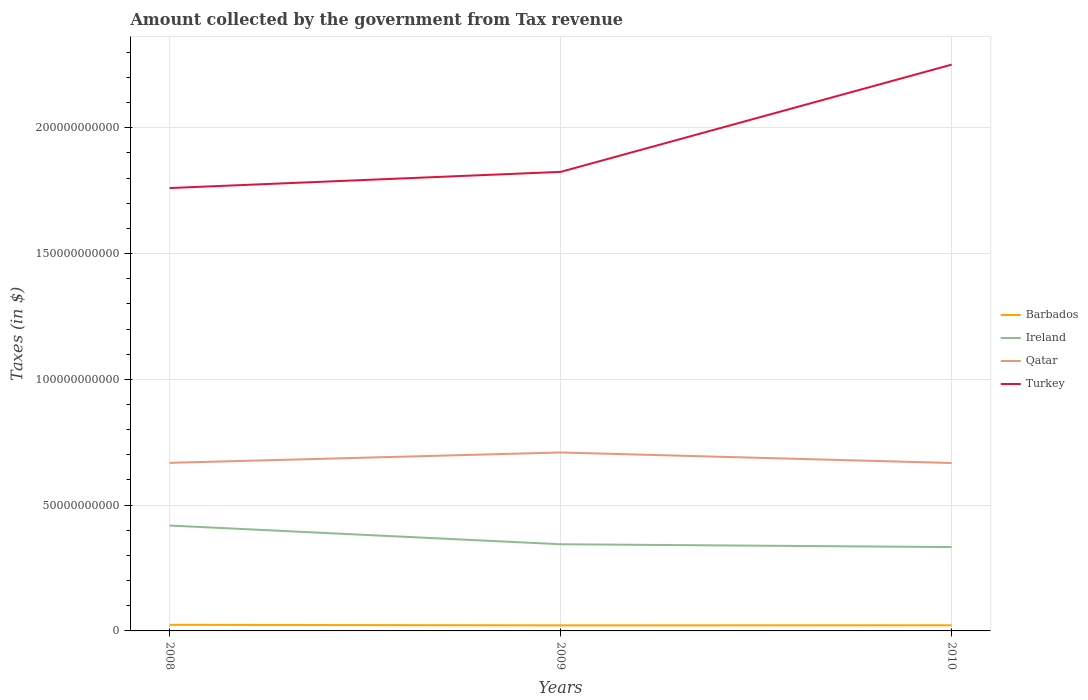Does the line corresponding to Barbados intersect with the line corresponding to Qatar?
Make the answer very short. No. Is the number of lines equal to the number of legend labels?
Provide a succinct answer. Yes. Across all years, what is the maximum amount collected by the government from tax revenue in Turkey?
Your answer should be compact. 1.76e+11. What is the total amount collected by the government from tax revenue in Turkey in the graph?
Your answer should be very brief. -4.91e+1. What is the difference between the highest and the second highest amount collected by the government from tax revenue in Turkey?
Give a very brief answer. 4.91e+1. Is the amount collected by the government from tax revenue in Ireland strictly greater than the amount collected by the government from tax revenue in Qatar over the years?
Provide a succinct answer. Yes. How many years are there in the graph?
Offer a terse response. 3. Does the graph contain grids?
Offer a very short reply. Yes. How many legend labels are there?
Provide a succinct answer. 4. What is the title of the graph?
Provide a short and direct response. Amount collected by the government from Tax revenue. What is the label or title of the X-axis?
Keep it short and to the point. Years. What is the label or title of the Y-axis?
Your answer should be compact. Taxes (in $). What is the Taxes (in $) of Barbados in 2008?
Offer a terse response. 2.43e+09. What is the Taxes (in $) of Ireland in 2008?
Make the answer very short. 4.19e+1. What is the Taxes (in $) of Qatar in 2008?
Your answer should be very brief. 6.68e+1. What is the Taxes (in $) of Turkey in 2008?
Keep it short and to the point. 1.76e+11. What is the Taxes (in $) in Barbados in 2009?
Make the answer very short. 2.21e+09. What is the Taxes (in $) in Ireland in 2009?
Make the answer very short. 3.45e+1. What is the Taxes (in $) in Qatar in 2009?
Make the answer very short. 7.09e+1. What is the Taxes (in $) in Turkey in 2009?
Your answer should be very brief. 1.82e+11. What is the Taxes (in $) of Barbados in 2010?
Offer a very short reply. 2.24e+09. What is the Taxes (in $) in Ireland in 2010?
Your answer should be very brief. 3.33e+1. What is the Taxes (in $) of Qatar in 2010?
Your answer should be compact. 6.67e+1. What is the Taxes (in $) of Turkey in 2010?
Give a very brief answer. 2.25e+11. Across all years, what is the maximum Taxes (in $) in Barbados?
Make the answer very short. 2.43e+09. Across all years, what is the maximum Taxes (in $) of Ireland?
Offer a terse response. 4.19e+1. Across all years, what is the maximum Taxes (in $) of Qatar?
Provide a succinct answer. 7.09e+1. Across all years, what is the maximum Taxes (in $) of Turkey?
Your answer should be compact. 2.25e+11. Across all years, what is the minimum Taxes (in $) of Barbados?
Ensure brevity in your answer.  2.21e+09. Across all years, what is the minimum Taxes (in $) of Ireland?
Provide a short and direct response. 3.33e+1. Across all years, what is the minimum Taxes (in $) in Qatar?
Your answer should be very brief. 6.67e+1. Across all years, what is the minimum Taxes (in $) in Turkey?
Your answer should be very brief. 1.76e+11. What is the total Taxes (in $) in Barbados in the graph?
Your answer should be compact. 6.88e+09. What is the total Taxes (in $) in Ireland in the graph?
Your response must be concise. 1.10e+11. What is the total Taxes (in $) of Qatar in the graph?
Ensure brevity in your answer.  2.04e+11. What is the total Taxes (in $) in Turkey in the graph?
Offer a terse response. 5.84e+11. What is the difference between the Taxes (in $) of Barbados in 2008 and that in 2009?
Ensure brevity in your answer.  2.26e+08. What is the difference between the Taxes (in $) of Ireland in 2008 and that in 2009?
Your response must be concise. 7.44e+09. What is the difference between the Taxes (in $) of Qatar in 2008 and that in 2009?
Give a very brief answer. -4.12e+09. What is the difference between the Taxes (in $) of Turkey in 2008 and that in 2009?
Your answer should be very brief. -6.43e+09. What is the difference between the Taxes (in $) of Barbados in 2008 and that in 2010?
Ensure brevity in your answer.  1.95e+08. What is the difference between the Taxes (in $) in Ireland in 2008 and that in 2010?
Give a very brief answer. 8.56e+09. What is the difference between the Taxes (in $) of Qatar in 2008 and that in 2010?
Provide a short and direct response. 6.57e+07. What is the difference between the Taxes (in $) in Turkey in 2008 and that in 2010?
Your response must be concise. -4.91e+1. What is the difference between the Taxes (in $) in Barbados in 2009 and that in 2010?
Provide a short and direct response. -3.17e+07. What is the difference between the Taxes (in $) in Ireland in 2009 and that in 2010?
Give a very brief answer. 1.13e+09. What is the difference between the Taxes (in $) in Qatar in 2009 and that in 2010?
Offer a very short reply. 4.18e+09. What is the difference between the Taxes (in $) in Turkey in 2009 and that in 2010?
Provide a succinct answer. -4.26e+1. What is the difference between the Taxes (in $) in Barbados in 2008 and the Taxes (in $) in Ireland in 2009?
Offer a terse response. -3.20e+1. What is the difference between the Taxes (in $) of Barbados in 2008 and the Taxes (in $) of Qatar in 2009?
Give a very brief answer. -6.85e+1. What is the difference between the Taxes (in $) of Barbados in 2008 and the Taxes (in $) of Turkey in 2009?
Make the answer very short. -1.80e+11. What is the difference between the Taxes (in $) in Ireland in 2008 and the Taxes (in $) in Qatar in 2009?
Give a very brief answer. -2.90e+1. What is the difference between the Taxes (in $) in Ireland in 2008 and the Taxes (in $) in Turkey in 2009?
Your answer should be very brief. -1.41e+11. What is the difference between the Taxes (in $) of Qatar in 2008 and the Taxes (in $) of Turkey in 2009?
Provide a succinct answer. -1.16e+11. What is the difference between the Taxes (in $) of Barbados in 2008 and the Taxes (in $) of Ireland in 2010?
Keep it short and to the point. -3.09e+1. What is the difference between the Taxes (in $) of Barbados in 2008 and the Taxes (in $) of Qatar in 2010?
Your answer should be compact. -6.43e+1. What is the difference between the Taxes (in $) in Barbados in 2008 and the Taxes (in $) in Turkey in 2010?
Your answer should be compact. -2.23e+11. What is the difference between the Taxes (in $) in Ireland in 2008 and the Taxes (in $) in Qatar in 2010?
Your response must be concise. -2.49e+1. What is the difference between the Taxes (in $) in Ireland in 2008 and the Taxes (in $) in Turkey in 2010?
Make the answer very short. -1.83e+11. What is the difference between the Taxes (in $) in Qatar in 2008 and the Taxes (in $) in Turkey in 2010?
Keep it short and to the point. -1.58e+11. What is the difference between the Taxes (in $) in Barbados in 2009 and the Taxes (in $) in Ireland in 2010?
Your response must be concise. -3.11e+1. What is the difference between the Taxes (in $) of Barbados in 2009 and the Taxes (in $) of Qatar in 2010?
Offer a very short reply. -6.45e+1. What is the difference between the Taxes (in $) of Barbados in 2009 and the Taxes (in $) of Turkey in 2010?
Offer a very short reply. -2.23e+11. What is the difference between the Taxes (in $) in Ireland in 2009 and the Taxes (in $) in Qatar in 2010?
Give a very brief answer. -3.23e+1. What is the difference between the Taxes (in $) of Ireland in 2009 and the Taxes (in $) of Turkey in 2010?
Keep it short and to the point. -1.91e+11. What is the difference between the Taxes (in $) in Qatar in 2009 and the Taxes (in $) in Turkey in 2010?
Give a very brief answer. -1.54e+11. What is the average Taxes (in $) in Barbados per year?
Offer a terse response. 2.29e+09. What is the average Taxes (in $) in Ireland per year?
Your answer should be compact. 3.66e+1. What is the average Taxes (in $) of Qatar per year?
Provide a succinct answer. 6.82e+1. What is the average Taxes (in $) of Turkey per year?
Give a very brief answer. 1.95e+11. In the year 2008, what is the difference between the Taxes (in $) of Barbados and Taxes (in $) of Ireland?
Offer a very short reply. -3.95e+1. In the year 2008, what is the difference between the Taxes (in $) in Barbados and Taxes (in $) in Qatar?
Make the answer very short. -6.44e+1. In the year 2008, what is the difference between the Taxes (in $) in Barbados and Taxes (in $) in Turkey?
Your answer should be compact. -1.74e+11. In the year 2008, what is the difference between the Taxes (in $) of Ireland and Taxes (in $) of Qatar?
Your answer should be very brief. -2.49e+1. In the year 2008, what is the difference between the Taxes (in $) in Ireland and Taxes (in $) in Turkey?
Your answer should be very brief. -1.34e+11. In the year 2008, what is the difference between the Taxes (in $) in Qatar and Taxes (in $) in Turkey?
Ensure brevity in your answer.  -1.09e+11. In the year 2009, what is the difference between the Taxes (in $) of Barbados and Taxes (in $) of Ireland?
Provide a short and direct response. -3.22e+1. In the year 2009, what is the difference between the Taxes (in $) of Barbados and Taxes (in $) of Qatar?
Offer a very short reply. -6.87e+1. In the year 2009, what is the difference between the Taxes (in $) in Barbados and Taxes (in $) in Turkey?
Your response must be concise. -1.80e+11. In the year 2009, what is the difference between the Taxes (in $) in Ireland and Taxes (in $) in Qatar?
Offer a very short reply. -3.65e+1. In the year 2009, what is the difference between the Taxes (in $) of Ireland and Taxes (in $) of Turkey?
Give a very brief answer. -1.48e+11. In the year 2009, what is the difference between the Taxes (in $) of Qatar and Taxes (in $) of Turkey?
Your answer should be very brief. -1.12e+11. In the year 2010, what is the difference between the Taxes (in $) in Barbados and Taxes (in $) in Ireland?
Provide a short and direct response. -3.11e+1. In the year 2010, what is the difference between the Taxes (in $) in Barbados and Taxes (in $) in Qatar?
Offer a terse response. -6.45e+1. In the year 2010, what is the difference between the Taxes (in $) of Barbados and Taxes (in $) of Turkey?
Provide a short and direct response. -2.23e+11. In the year 2010, what is the difference between the Taxes (in $) in Ireland and Taxes (in $) in Qatar?
Ensure brevity in your answer.  -3.34e+1. In the year 2010, what is the difference between the Taxes (in $) in Ireland and Taxes (in $) in Turkey?
Provide a succinct answer. -1.92e+11. In the year 2010, what is the difference between the Taxes (in $) of Qatar and Taxes (in $) of Turkey?
Your answer should be very brief. -1.58e+11. What is the ratio of the Taxes (in $) in Barbados in 2008 to that in 2009?
Offer a very short reply. 1.1. What is the ratio of the Taxes (in $) of Ireland in 2008 to that in 2009?
Your response must be concise. 1.22. What is the ratio of the Taxes (in $) of Qatar in 2008 to that in 2009?
Make the answer very short. 0.94. What is the ratio of the Taxes (in $) in Turkey in 2008 to that in 2009?
Your answer should be very brief. 0.96. What is the ratio of the Taxes (in $) in Barbados in 2008 to that in 2010?
Keep it short and to the point. 1.09. What is the ratio of the Taxes (in $) in Ireland in 2008 to that in 2010?
Offer a terse response. 1.26. What is the ratio of the Taxes (in $) in Qatar in 2008 to that in 2010?
Your response must be concise. 1. What is the ratio of the Taxes (in $) in Turkey in 2008 to that in 2010?
Your answer should be compact. 0.78. What is the ratio of the Taxes (in $) of Barbados in 2009 to that in 2010?
Keep it short and to the point. 0.99. What is the ratio of the Taxes (in $) of Ireland in 2009 to that in 2010?
Keep it short and to the point. 1.03. What is the ratio of the Taxes (in $) of Qatar in 2009 to that in 2010?
Your answer should be compact. 1.06. What is the ratio of the Taxes (in $) of Turkey in 2009 to that in 2010?
Provide a short and direct response. 0.81. What is the difference between the highest and the second highest Taxes (in $) in Barbados?
Make the answer very short. 1.95e+08. What is the difference between the highest and the second highest Taxes (in $) in Ireland?
Make the answer very short. 7.44e+09. What is the difference between the highest and the second highest Taxes (in $) of Qatar?
Provide a succinct answer. 4.12e+09. What is the difference between the highest and the second highest Taxes (in $) of Turkey?
Your response must be concise. 4.26e+1. What is the difference between the highest and the lowest Taxes (in $) of Barbados?
Keep it short and to the point. 2.26e+08. What is the difference between the highest and the lowest Taxes (in $) of Ireland?
Your response must be concise. 8.56e+09. What is the difference between the highest and the lowest Taxes (in $) in Qatar?
Give a very brief answer. 4.18e+09. What is the difference between the highest and the lowest Taxes (in $) of Turkey?
Your answer should be compact. 4.91e+1. 